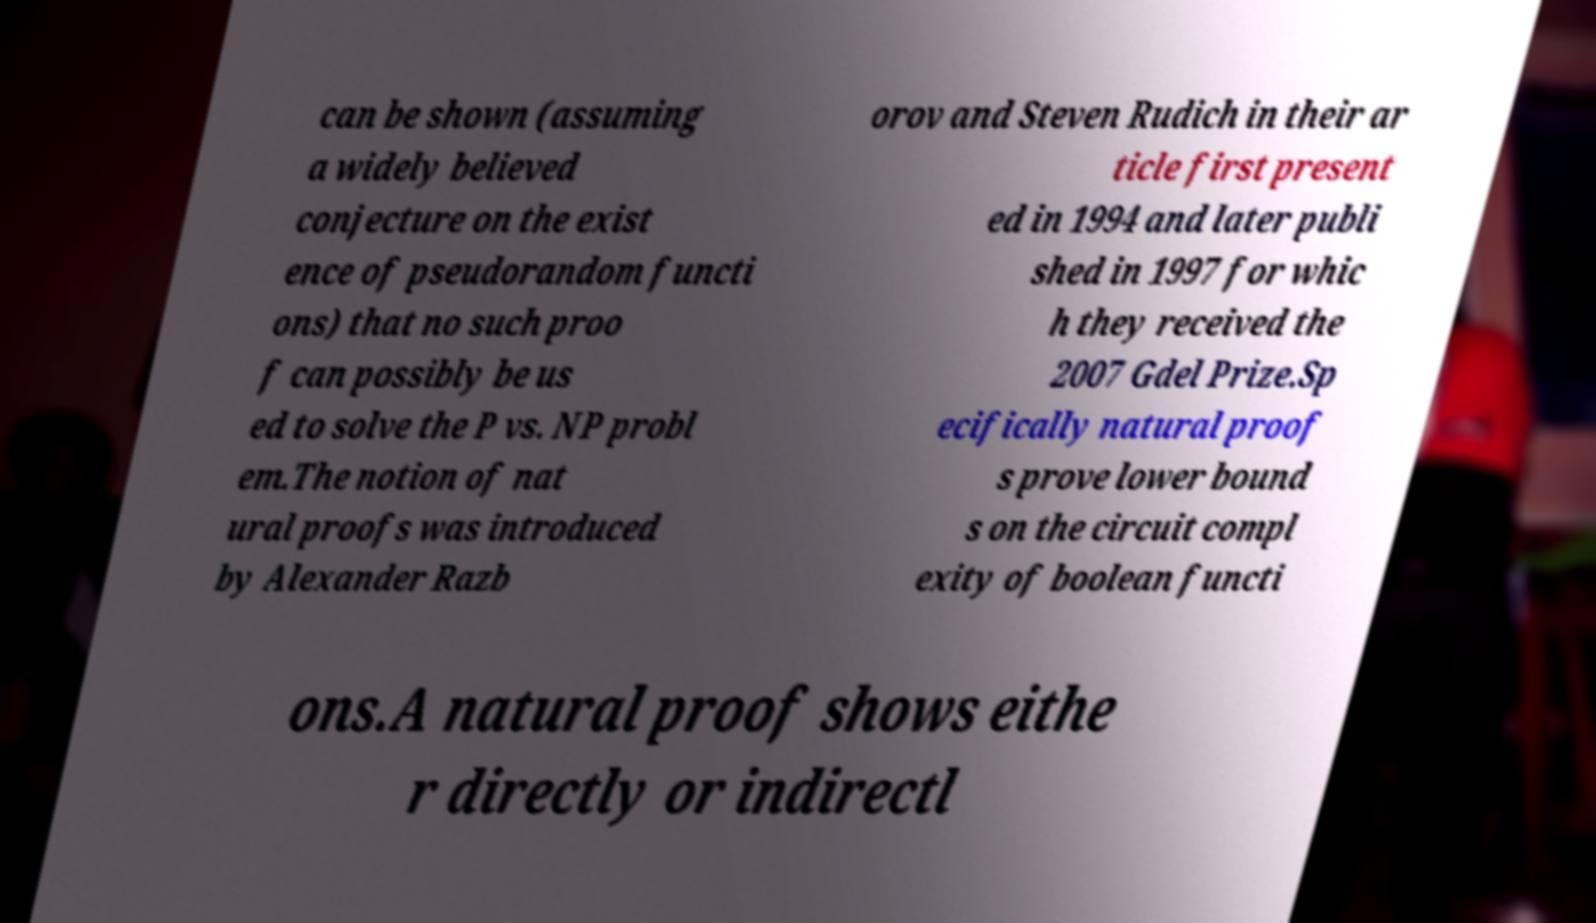What messages or text are displayed in this image? I need them in a readable, typed format. can be shown (assuming a widely believed conjecture on the exist ence of pseudorandom functi ons) that no such proo f can possibly be us ed to solve the P vs. NP probl em.The notion of nat ural proofs was introduced by Alexander Razb orov and Steven Rudich in their ar ticle first present ed in 1994 and later publi shed in 1997 for whic h they received the 2007 Gdel Prize.Sp ecifically natural proof s prove lower bound s on the circuit compl exity of boolean functi ons.A natural proof shows eithe r directly or indirectl 